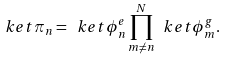Convert formula to latex. <formula><loc_0><loc_0><loc_500><loc_500>\ k e t { \pi _ { n } } = \ k e t { \phi ^ { e } _ { n } } \prod _ { m \ne n } ^ { N } \ k e t { \phi ^ { g } _ { m } } .</formula> 